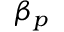Convert formula to latex. <formula><loc_0><loc_0><loc_500><loc_500>\beta _ { p }</formula> 